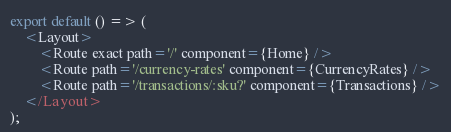Convert code to text. <code><loc_0><loc_0><loc_500><loc_500><_TypeScript_>
export default () => (
    <Layout>
        <Route exact path='/' component={Home} />
        <Route path='/currency-rates' component={CurrencyRates} />
        <Route path='/transactions/:sku?' component={Transactions} />
    </Layout>
);
</code> 